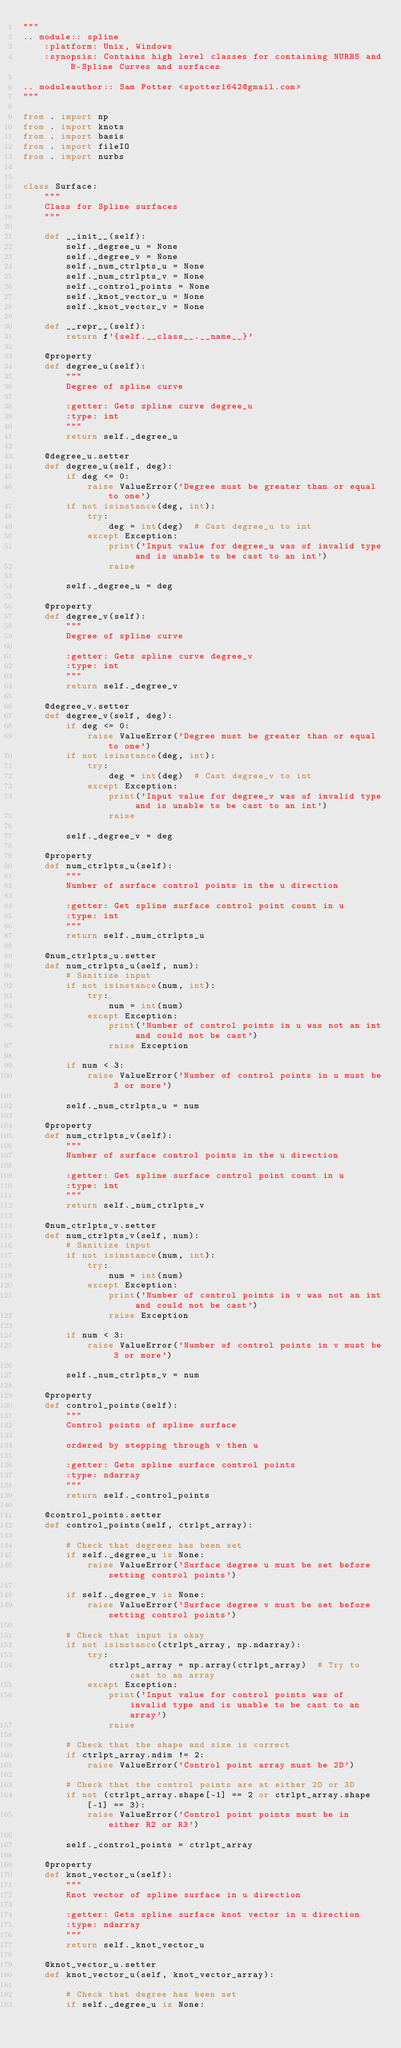<code> <loc_0><loc_0><loc_500><loc_500><_Python_>"""
.. module:: spline
    :platform: Unix, Windows
    :synopsis: Contains high level classes for containing NURBS and B-Spline Curves and surfaces

.. moduleauthor:: Sam Potter <spotter1642@gmail.com>
"""

from . import np
from . import knots
from . import basis
from . import fileIO
from . import nurbs


class Surface:
    """
    Class for Spline surfaces
    """

    def __init__(self):
        self._degree_u = None
        self._degree_v = None
        self._num_ctrlpts_u = None
        self._num_ctrlpts_v = None
        self._control_points = None
        self._knot_vector_u = None
        self._knot_vector_v = None

    def __repr__(self):
        return f'{self.__class__.__name__}'

    @property
    def degree_u(self):
        """
        Degree of spline curve

        :getter: Gets spline curve degree_u
        :type: int
        """
        return self._degree_u

    @degree_u.setter
    def degree_u(self, deg):
        if deg <= 0:
            raise ValueError('Degree must be greater than or equal to one')
        if not isinstance(deg, int):
            try:
                deg = int(deg)  # Cast degree_u to int
            except Exception:
                print('Input value for degree_u was of invalid type and is unable to be cast to an int')
                raise

        self._degree_u = deg

    @property
    def degree_v(self):
        """
        Degree of spline curve

        :getter: Gets spline curve degree_v
        :type: int
        """
        return self._degree_v

    @degree_v.setter
    def degree_v(self, deg):
        if deg <= 0:
            raise ValueError('Degree must be greater than or equal to one')
        if not isinstance(deg, int):
            try:
                deg = int(deg)  # Cast degree_v to int
            except Exception:
                print('Input value for degree_v was of invalid type and is unable to be cast to an int')
                raise

        self._degree_v = deg

    @property
    def num_ctrlpts_u(self):
        """
        Number of surface control points in the u direction

        :getter: Get spline surface control point count in u
        :type: int
        """
        return self._num_ctrlpts_u

    @num_ctrlpts_u.setter
    def num_ctrlpts_u(self, num):
        # Sanitize input
        if not isinstance(num, int):
            try:
                num = int(num)
            except Exception:
                print('Number of control points in u was not an int and could not be cast')
                raise Exception

        if num < 3:
            raise ValueError('Number of control points in u must be 3 or more')

        self._num_ctrlpts_u = num

    @property
    def num_ctrlpts_v(self):
        """
        Number of surface control points in the u direction

        :getter: Get spline surface control point count in u
        :type: int
        """
        return self._num_ctrlpts_v

    @num_ctrlpts_v.setter
    def num_ctrlpts_v(self, num):
        # Sanitize input
        if not isinstance(num, int):
            try:
                num = int(num)
            except Exception:
                print('Number of control points in v was not an int and could not be cast')
                raise Exception

        if num < 3:
            raise ValueError('Number of control points in v must be 3 or more')

        self._num_ctrlpts_v = num

    @property
    def control_points(self):
        """
        Control points of spline surface

        ordered by stepping through v then u

        :getter: Gets spline surface control points
        :type: ndarray
        """
        return self._control_points

    @control_points.setter
    def control_points(self, ctrlpt_array):

        # Check that degrees has been set
        if self._degree_u is None:
            raise ValueError('Surface degree u must be set before setting control points')

        if self._degree_v is None:
            raise ValueError('Surface degree v must be set before setting control points')

        # Check that input is okay
        if not isinstance(ctrlpt_array, np.ndarray):
            try:
                ctrlpt_array = np.array(ctrlpt_array)  # Try to cast to an array
            except Exception:
                print('Input value for control points was of invalid type and is unable to be cast to an array')
                raise

        # Check that the shape and size is correct
        if ctrlpt_array.ndim != 2:
            raise ValueError('Control point array must be 2D')

        # Check that the control points are at either 2D or 3D
        if not (ctrlpt_array.shape[-1] == 2 or ctrlpt_array.shape[-1] == 3):
            raise ValueError('Control point points must be in either R2 or R3')

        self._control_points = ctrlpt_array

    @property
    def knot_vector_u(self):
        """
        Knot vector of spline surface in u direction

        :getter: Gets spline surface knot vector in u direction
        :type: ndarray
        """
        return self._knot_vector_u

    @knot_vector_u.setter
    def knot_vector_u(self, knot_vector_array):

        # Check that degree has been set
        if self._degree_u is None:</code> 